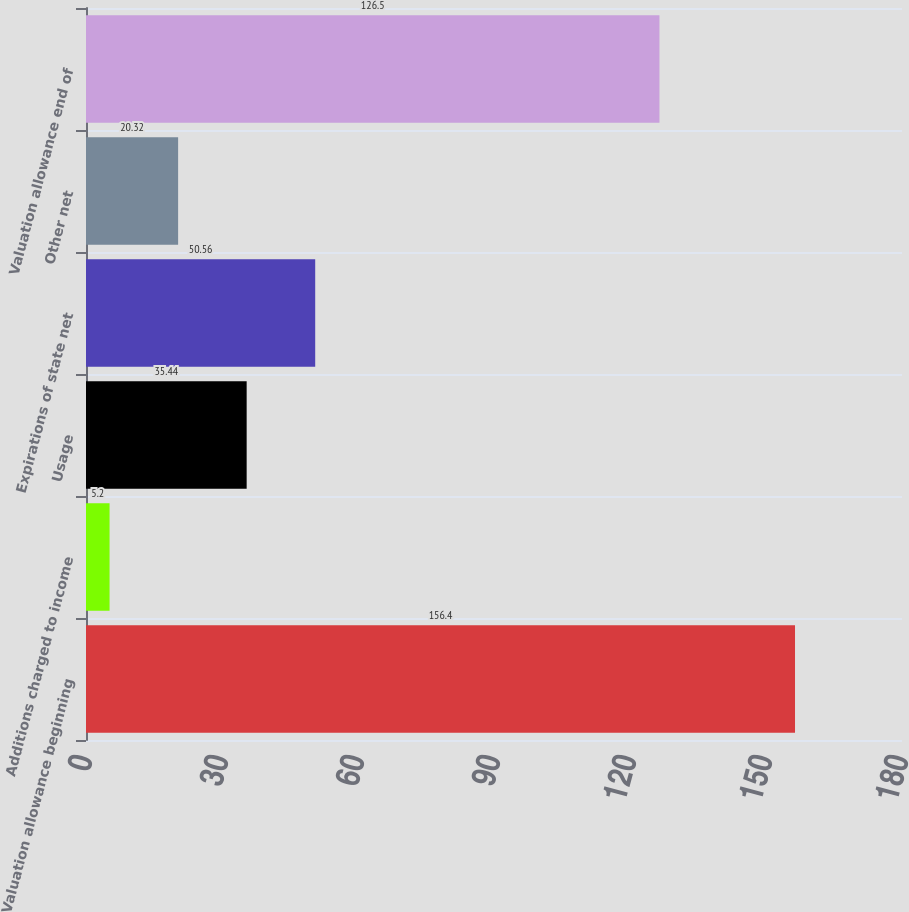Convert chart to OTSL. <chart><loc_0><loc_0><loc_500><loc_500><bar_chart><fcel>Valuation allowance beginning<fcel>Additions charged to income<fcel>Usage<fcel>Expirations of state net<fcel>Other net<fcel>Valuation allowance end of<nl><fcel>156.4<fcel>5.2<fcel>35.44<fcel>50.56<fcel>20.32<fcel>126.5<nl></chart> 